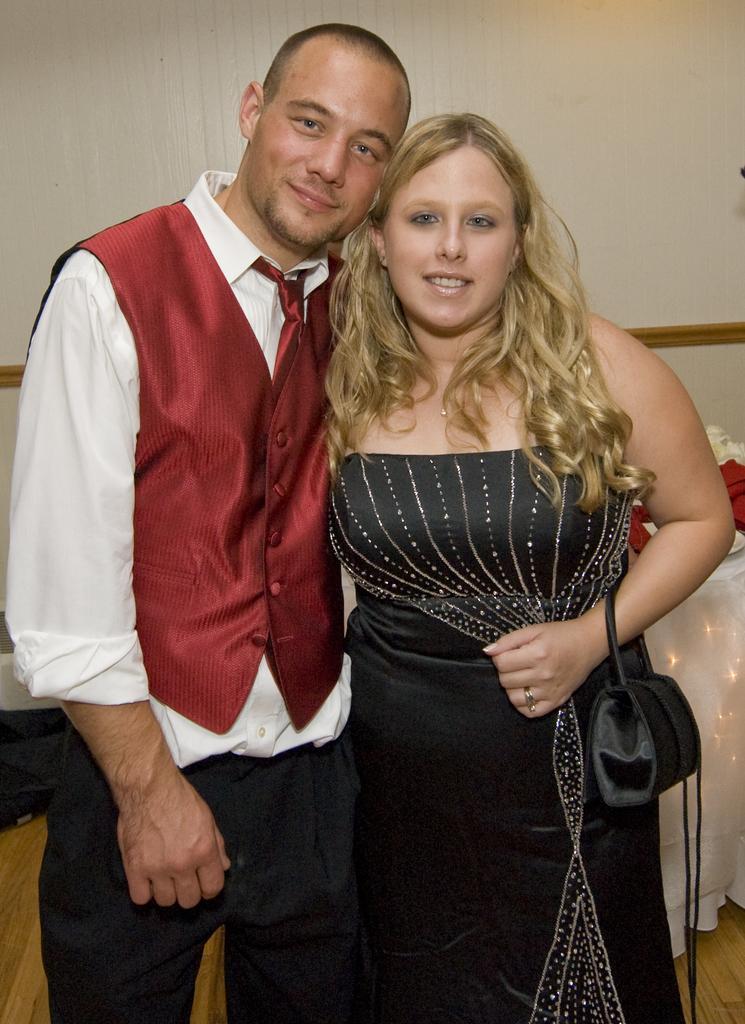In one or two sentences, can you explain what this image depicts? In this image in the foreground there is one man and one woman who are standing and woman is holding a hand bag, and in the background there is a table, cloth and some objects and there is a wall. At the bottom there is floor. 